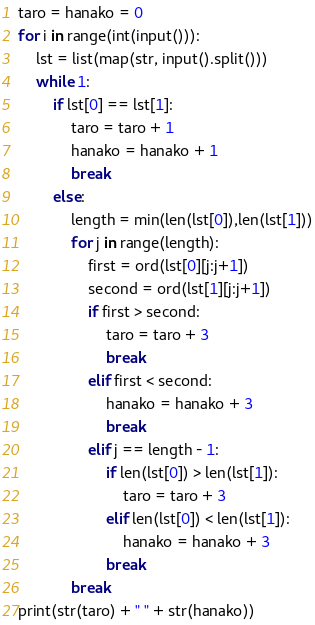<code> <loc_0><loc_0><loc_500><loc_500><_Python_>taro = hanako = 0
for i in range(int(input())):
    lst = list(map(str, input().split()))
    while 1:
        if lst[0] == lst[1]:
            taro = taro + 1
            hanako = hanako + 1
            break
        else:
            length = min(len(lst[0]),len(lst[1]))
            for j in range(length):
                first = ord(lst[0][j:j+1])
                second = ord(lst[1][j:j+1])
                if first > second:
                    taro = taro + 3
                    break
                elif first < second:
                    hanako = hanako + 3
                    break
                elif j == length - 1:
                    if len(lst[0]) > len(lst[1]):
                        taro = taro + 3
                    elif len(lst[0]) < len(lst[1]):
                        hanako = hanako + 3
                    break
            break
print(str(taro) + " " + str(hanako))
</code> 